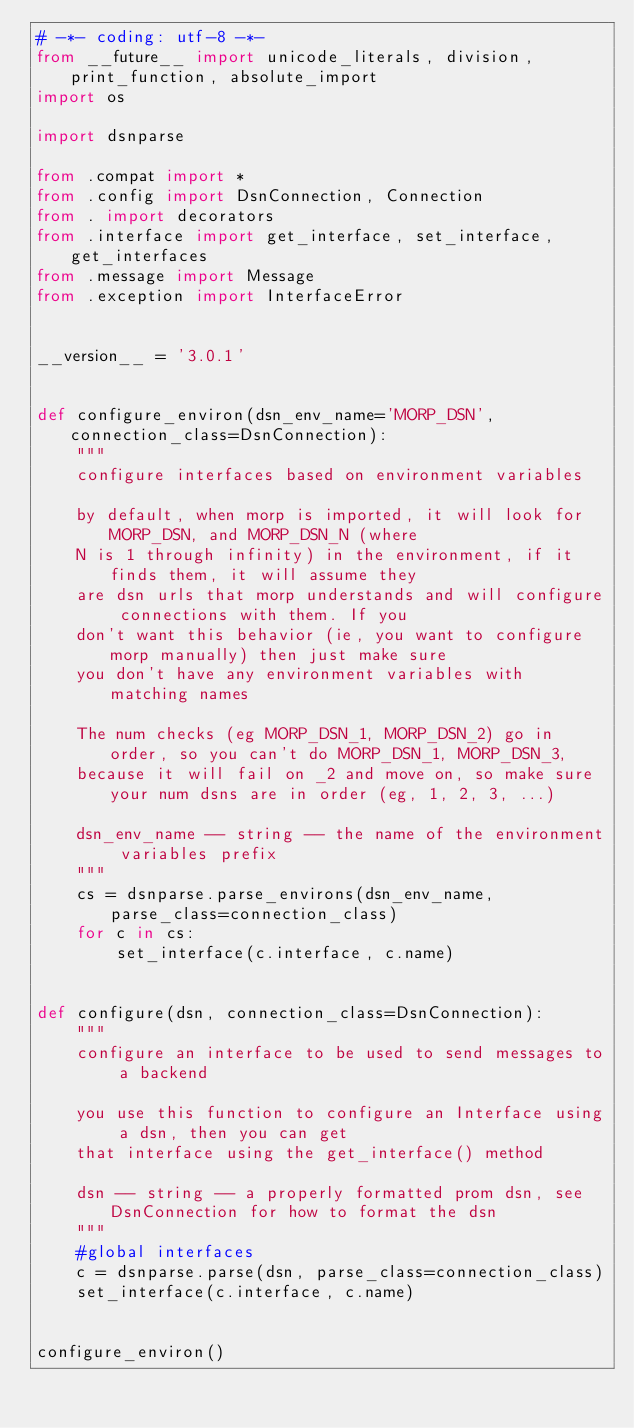<code> <loc_0><loc_0><loc_500><loc_500><_Python_># -*- coding: utf-8 -*-
from __future__ import unicode_literals, division, print_function, absolute_import
import os

import dsnparse

from .compat import *
from .config import DsnConnection, Connection
from . import decorators
from .interface import get_interface, set_interface, get_interfaces
from .message import Message
from .exception import InterfaceError


__version__ = '3.0.1'


def configure_environ(dsn_env_name='MORP_DSN', connection_class=DsnConnection):
    """
    configure interfaces based on environment variables

    by default, when morp is imported, it will look for MORP_DSN, and MORP_DSN_N (where
    N is 1 through infinity) in the environment, if it finds them, it will assume they
    are dsn urls that morp understands and will configure connections with them. If you
    don't want this behavior (ie, you want to configure morp manually) then just make sure
    you don't have any environment variables with matching names

    The num checks (eg MORP_DSN_1, MORP_DSN_2) go in order, so you can't do MORP_DSN_1, MORP_DSN_3,
    because it will fail on _2 and move on, so make sure your num dsns are in order (eg, 1, 2, 3, ...)

    dsn_env_name -- string -- the name of the environment variables prefix
    """
    cs = dsnparse.parse_environs(dsn_env_name, parse_class=connection_class)
    for c in cs:
        set_interface(c.interface, c.name)


def configure(dsn, connection_class=DsnConnection):
    """
    configure an interface to be used to send messages to a backend

    you use this function to configure an Interface using a dsn, then you can get
    that interface using the get_interface() method

    dsn -- string -- a properly formatted prom dsn, see DsnConnection for how to format the dsn
    """
    #global interfaces
    c = dsnparse.parse(dsn, parse_class=connection_class)
    set_interface(c.interface, c.name)


configure_environ()

</code> 